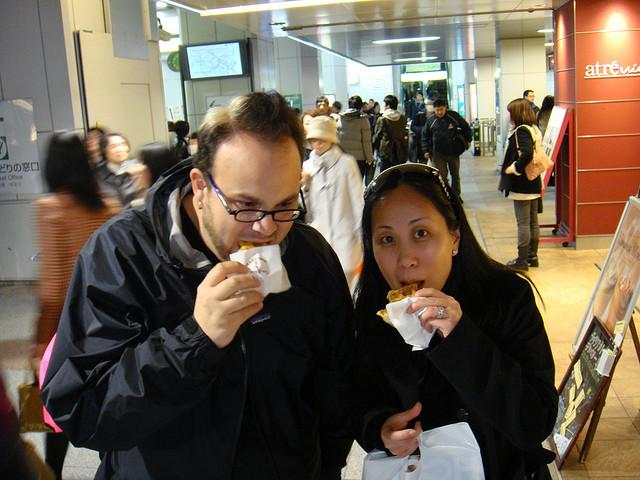Why did this couple take a break? Please explain your reasoning. hunger. The couple is hungry. 